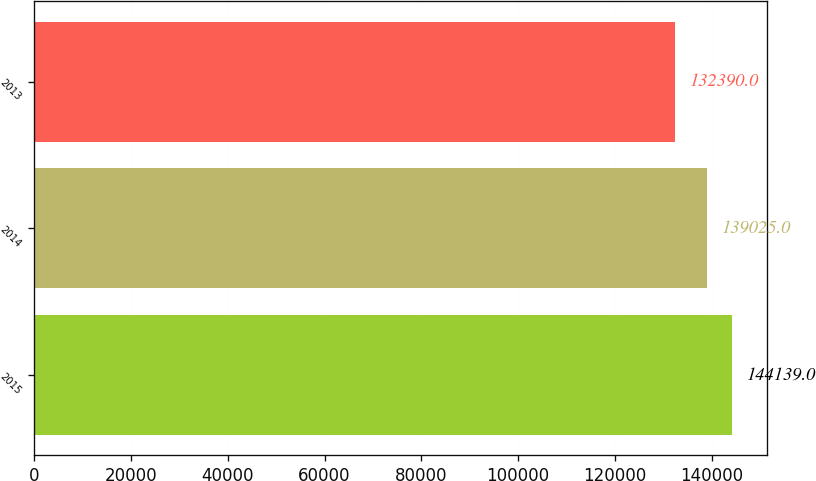Convert chart. <chart><loc_0><loc_0><loc_500><loc_500><bar_chart><fcel>2015<fcel>2014<fcel>2013<nl><fcel>144139<fcel>139025<fcel>132390<nl></chart> 